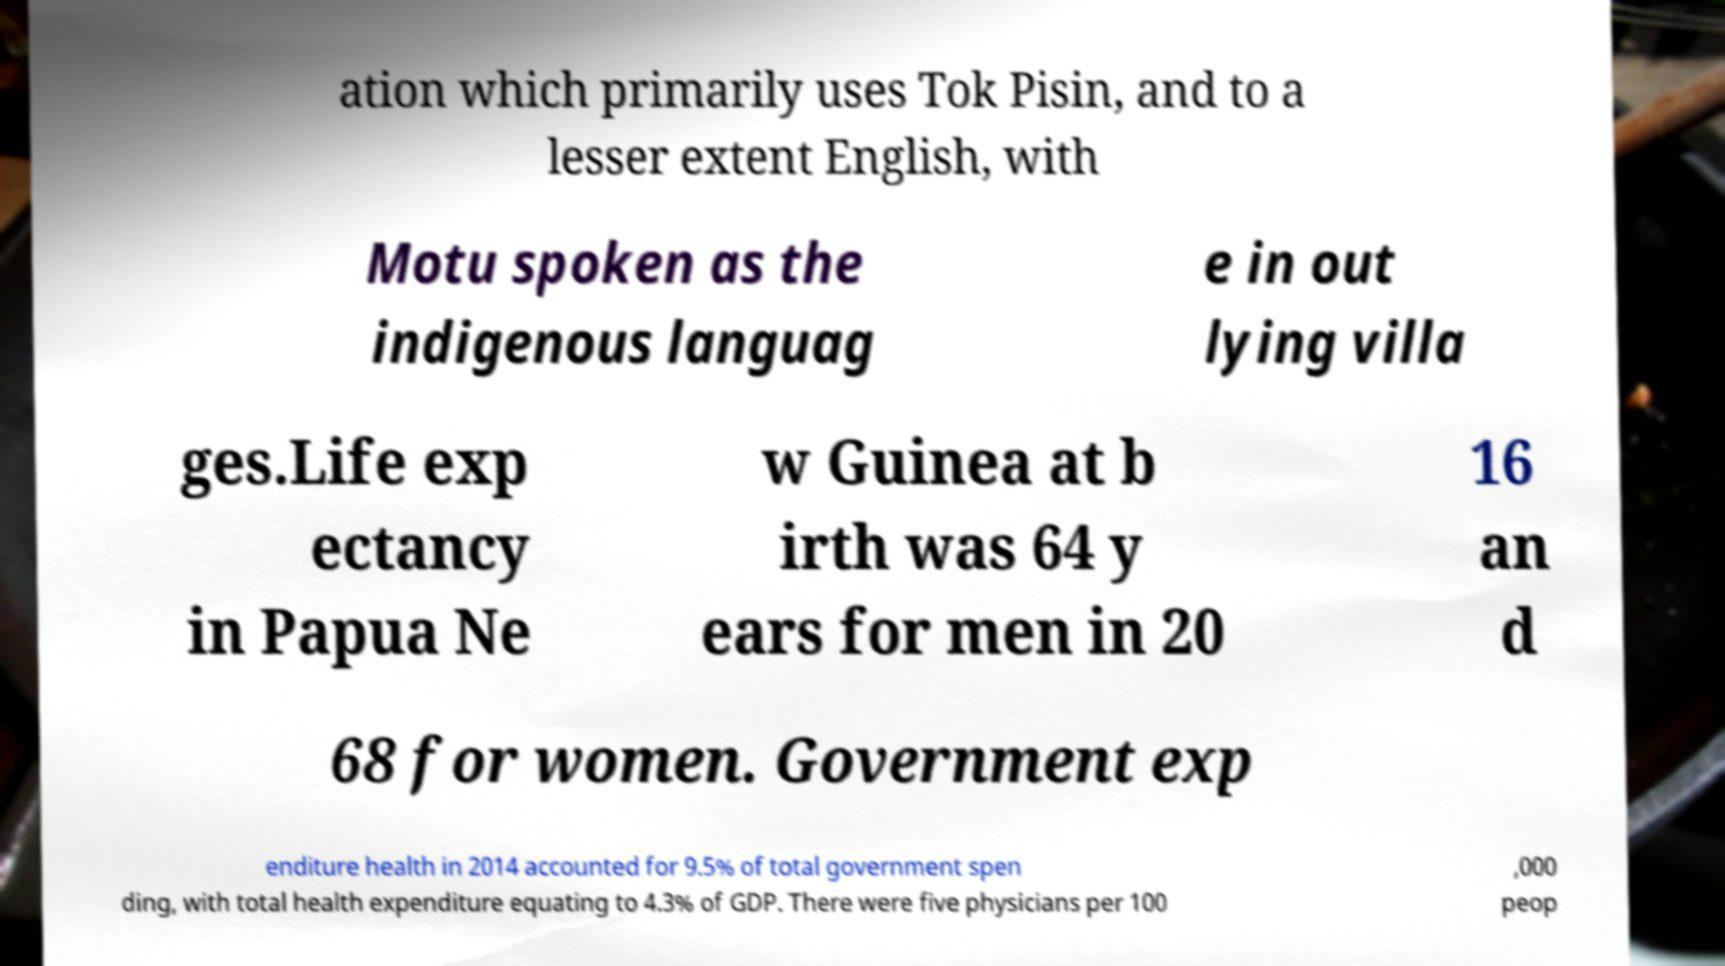What messages or text are displayed in this image? I need them in a readable, typed format. ation which primarily uses Tok Pisin, and to a lesser extent English, with Motu spoken as the indigenous languag e in out lying villa ges.Life exp ectancy in Papua Ne w Guinea at b irth was 64 y ears for men in 20 16 an d 68 for women. Government exp enditure health in 2014 accounted for 9.5% of total government spen ding, with total health expenditure equating to 4.3% of GDP. There were five physicians per 100 ,000 peop 